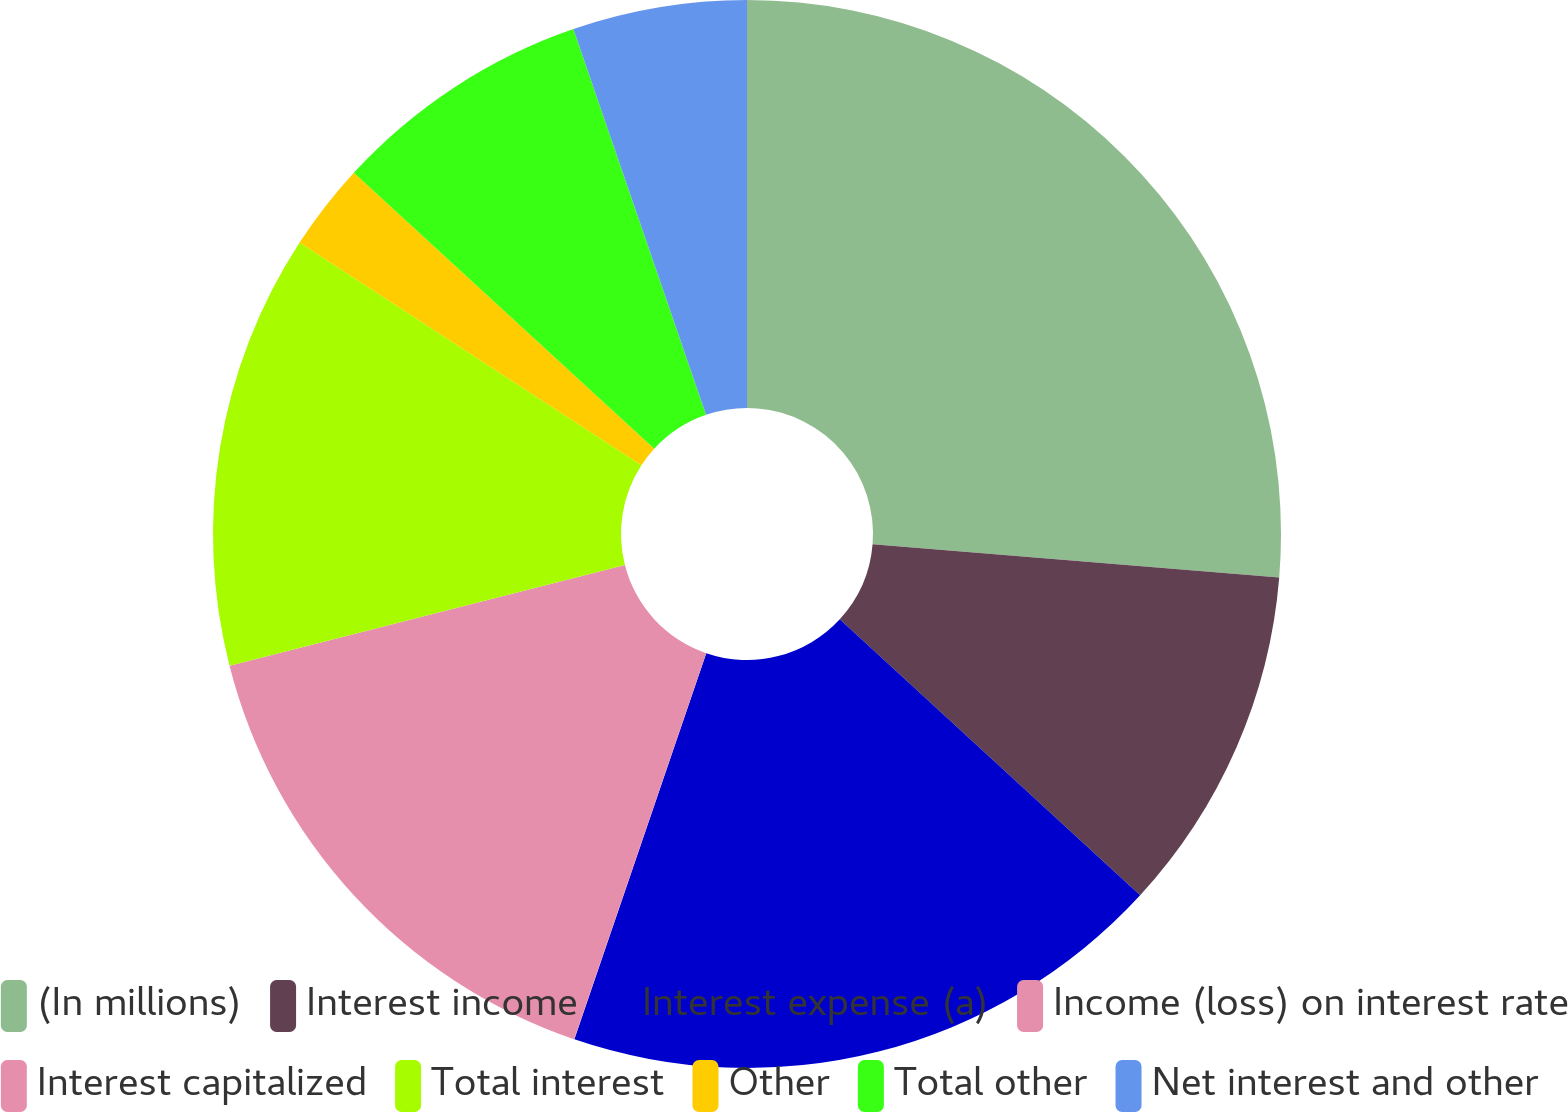<chart> <loc_0><loc_0><loc_500><loc_500><pie_chart><fcel>(In millions)<fcel>Interest income<fcel>Interest expense (a)<fcel>Income (loss) on interest rate<fcel>Interest capitalized<fcel>Total interest<fcel>Other<fcel>Total other<fcel>Net interest and other<nl><fcel>26.3%<fcel>10.53%<fcel>18.41%<fcel>0.01%<fcel>15.78%<fcel>13.16%<fcel>2.64%<fcel>7.9%<fcel>5.27%<nl></chart> 